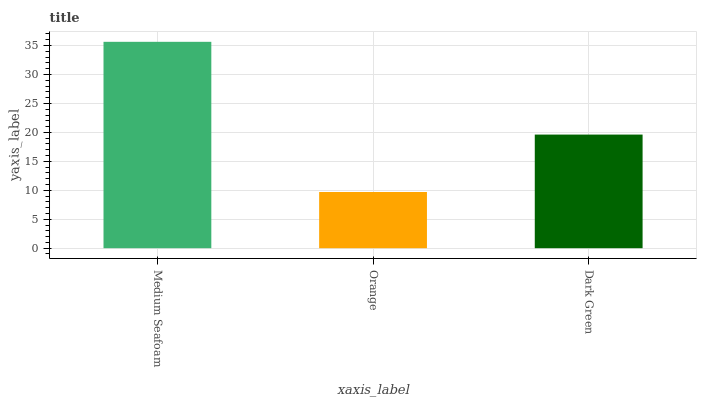Is Orange the minimum?
Answer yes or no. Yes. Is Medium Seafoam the maximum?
Answer yes or no. Yes. Is Dark Green the minimum?
Answer yes or no. No. Is Dark Green the maximum?
Answer yes or no. No. Is Dark Green greater than Orange?
Answer yes or no. Yes. Is Orange less than Dark Green?
Answer yes or no. Yes. Is Orange greater than Dark Green?
Answer yes or no. No. Is Dark Green less than Orange?
Answer yes or no. No. Is Dark Green the high median?
Answer yes or no. Yes. Is Dark Green the low median?
Answer yes or no. Yes. Is Orange the high median?
Answer yes or no. No. Is Orange the low median?
Answer yes or no. No. 